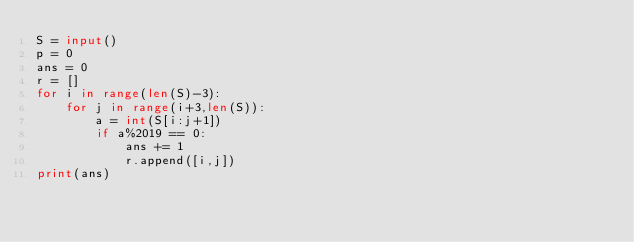Convert code to text. <code><loc_0><loc_0><loc_500><loc_500><_Python_>S = input()
p = 0
ans = 0
r = []
for i in range(len(S)-3):
    for j in range(i+3,len(S)):
        a = int(S[i:j+1])
        if a%2019 == 0:
            ans += 1
            r.append([i,j])
print(ans)</code> 